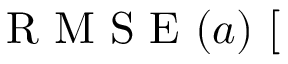Convert formula to latex. <formula><loc_0><loc_0><loc_500><loc_500>R M S E ( a ) [ \</formula> 